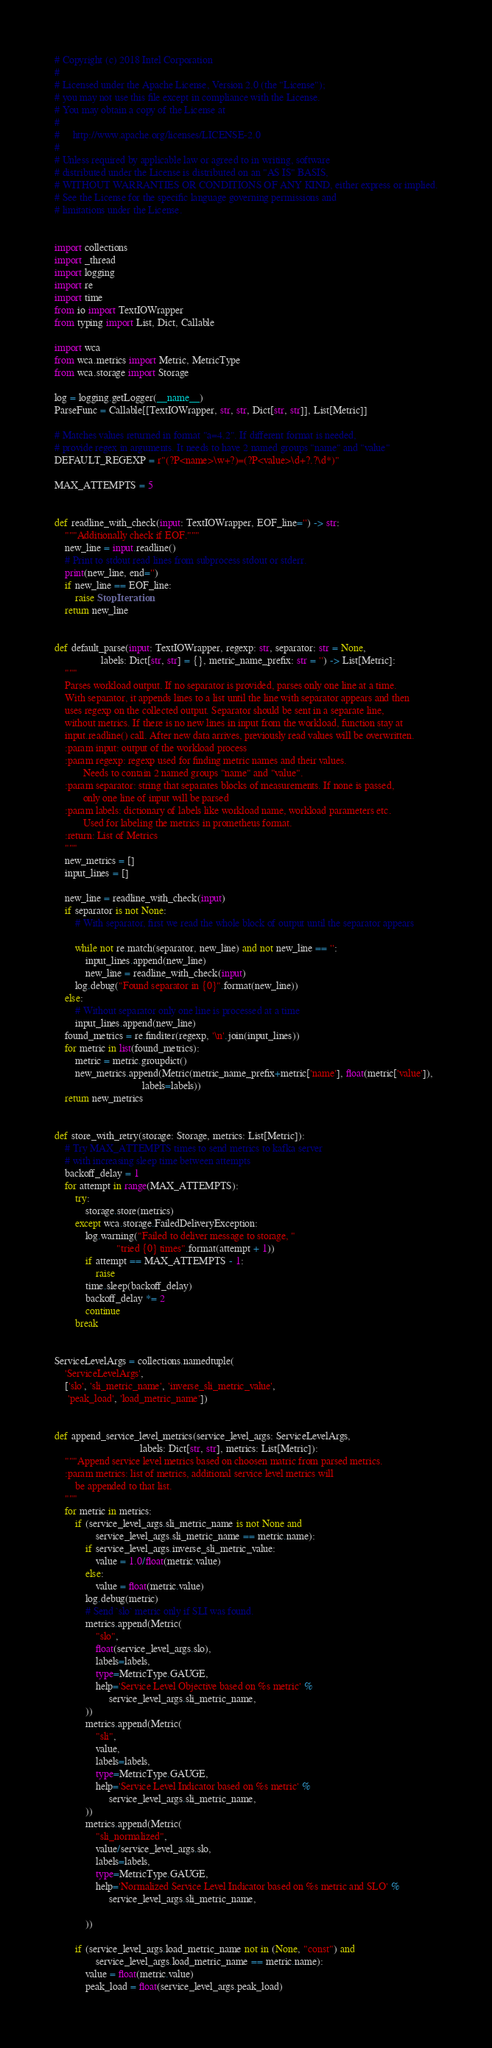<code> <loc_0><loc_0><loc_500><loc_500><_Python_># Copyright (c) 2018 Intel Corporation
#
# Licensed under the Apache License, Version 2.0 (the "License");
# you may not use this file except in compliance with the License.
# You may obtain a copy of the License at
#
#     http://www.apache.org/licenses/LICENSE-2.0
#
# Unless required by applicable law or agreed to in writing, software
# distributed under the License is distributed on an "AS IS" BASIS,
# WITHOUT WARRANTIES OR CONDITIONS OF ANY KIND, either express or implied.
# See the License for the specific language governing permissions and
# limitations under the License.


import collections
import _thread
import logging
import re
import time
from io import TextIOWrapper
from typing import List, Dict, Callable

import wca
from wca.metrics import Metric, MetricType
from wca.storage import Storage

log = logging.getLogger(__name__)
ParseFunc = Callable[[TextIOWrapper, str, str, Dict[str, str]], List[Metric]]

# Matches values returned in format "a=4.2". If different format is needed,
# provide regex in arguments. It needs to have 2 named groups "name" and "value"
DEFAULT_REGEXP = r"(?P<name>\w+?)=(?P<value>\d+?.?\d*)"

MAX_ATTEMPTS = 5


def readline_with_check(input: TextIOWrapper, EOF_line='') -> str:
    """Additionally check if EOF."""
    new_line = input.readline()
    # Print to stdout read lines from subprocess stdout or stderr.
    print(new_line, end='')
    if new_line == EOF_line:
        raise StopIteration
    return new_line


def default_parse(input: TextIOWrapper, regexp: str, separator: str = None,
                  labels: Dict[str, str] = {}, metric_name_prefix: str = '') -> List[Metric]:
    """
    Parses workload output. If no separator is provided, parses only one line at a time.
    With separator, it appends lines to a list until the line with separator appears and then
    uses regexp on the collected output. Separator should be sent in a separate line,
    without metrics. If there is no new lines in input from the workload, function stay at
    input.readline() call. After new data arrives, previously read values will be overwritten.
    :param input: output of the workload process
    :param regexp: regexp used for finding metric names and their values.
           Needs to contain 2 named groups "name" and "value".
    :param separator: string that separates blocks of measurements. If none is passed,
           only one line of input will be parsed
    :param labels: dictionary of labels like workload name, workload parameters etc.
           Used for labeling the metrics in prometheus format.
    :return: List of Metrics
    """
    new_metrics = []
    input_lines = []

    new_line = readline_with_check(input)
    if separator is not None:
        # With separator, first we read the whole block of output until the separator appears

        while not re.match(separator, new_line) and not new_line == '':
            input_lines.append(new_line)
            new_line = readline_with_check(input)
        log.debug("Found separator in {0}".format(new_line))
    else:
        # Without separator only one line is processed at a time
        input_lines.append(new_line)
    found_metrics = re.finditer(regexp, '\n'.join(input_lines))
    for metric in list(found_metrics):
        metric = metric.groupdict()
        new_metrics.append(Metric(metric_name_prefix+metric['name'], float(metric['value']),
                                  labels=labels))
    return new_metrics


def store_with_retry(storage: Storage, metrics: List[Metric]):
    # Try MAX_ATTEMPTS times to send metrics to kafka server
    # with increasing sleep time between attempts
    backoff_delay = 1
    for attempt in range(MAX_ATTEMPTS):
        try:
            storage.store(metrics)
        except wca.storage.FailedDeliveryException:
            log.warning("Failed to deliver message to storage, "
                        "tried {0} times".format(attempt + 1))
            if attempt == MAX_ATTEMPTS - 1:
                raise
            time.sleep(backoff_delay)
            backoff_delay *= 2
            continue
        break


ServiceLevelArgs = collections.namedtuple(
    'ServiceLevelArgs',
    ['slo', 'sli_metric_name', 'inverse_sli_metric_value',
     'peak_load', 'load_metric_name'])


def append_service_level_metrics(service_level_args: ServiceLevelArgs,
                                 labels: Dict[str, str], metrics: List[Metric]):
    """Append service level metrics based on choosen matric from parsed metrics.
    :param metrics: list of metrics, additional service level metrics will
        be appended to that list.
    """
    for metric in metrics:
        if (service_level_args.sli_metric_name is not None and
                service_level_args.sli_metric_name == metric.name):
            if service_level_args.inverse_sli_metric_value:
                value = 1.0/float(metric.value)
            else:
                value = float(metric.value)
            log.debug(metric)
            # Send `slo` metric only if SLI was found.
            metrics.append(Metric(
                "slo",
                float(service_level_args.slo),
                labels=labels,
                type=MetricType.GAUGE,
                help='Service Level Objective based on %s metric' %
                     service_level_args.sli_metric_name,
            ))
            metrics.append(Metric(
                "sli",
                value,
                labels=labels,
                type=MetricType.GAUGE,
                help='Service Level Indicator based on %s metric' %
                     service_level_args.sli_metric_name,
            ))
            metrics.append(Metric(
                "sli_normalized",
                value/service_level_args.slo,
                labels=labels,
                type=MetricType.GAUGE,
                help='Normalized Service Level Indicator based on %s metric and SLO' %
                     service_level_args.sli_metric_name,

            ))

        if (service_level_args.load_metric_name not in (None, "const") and
                service_level_args.load_metric_name == metric.name):
            value = float(metric.value)
            peak_load = float(service_level_args.peak_load)</code> 